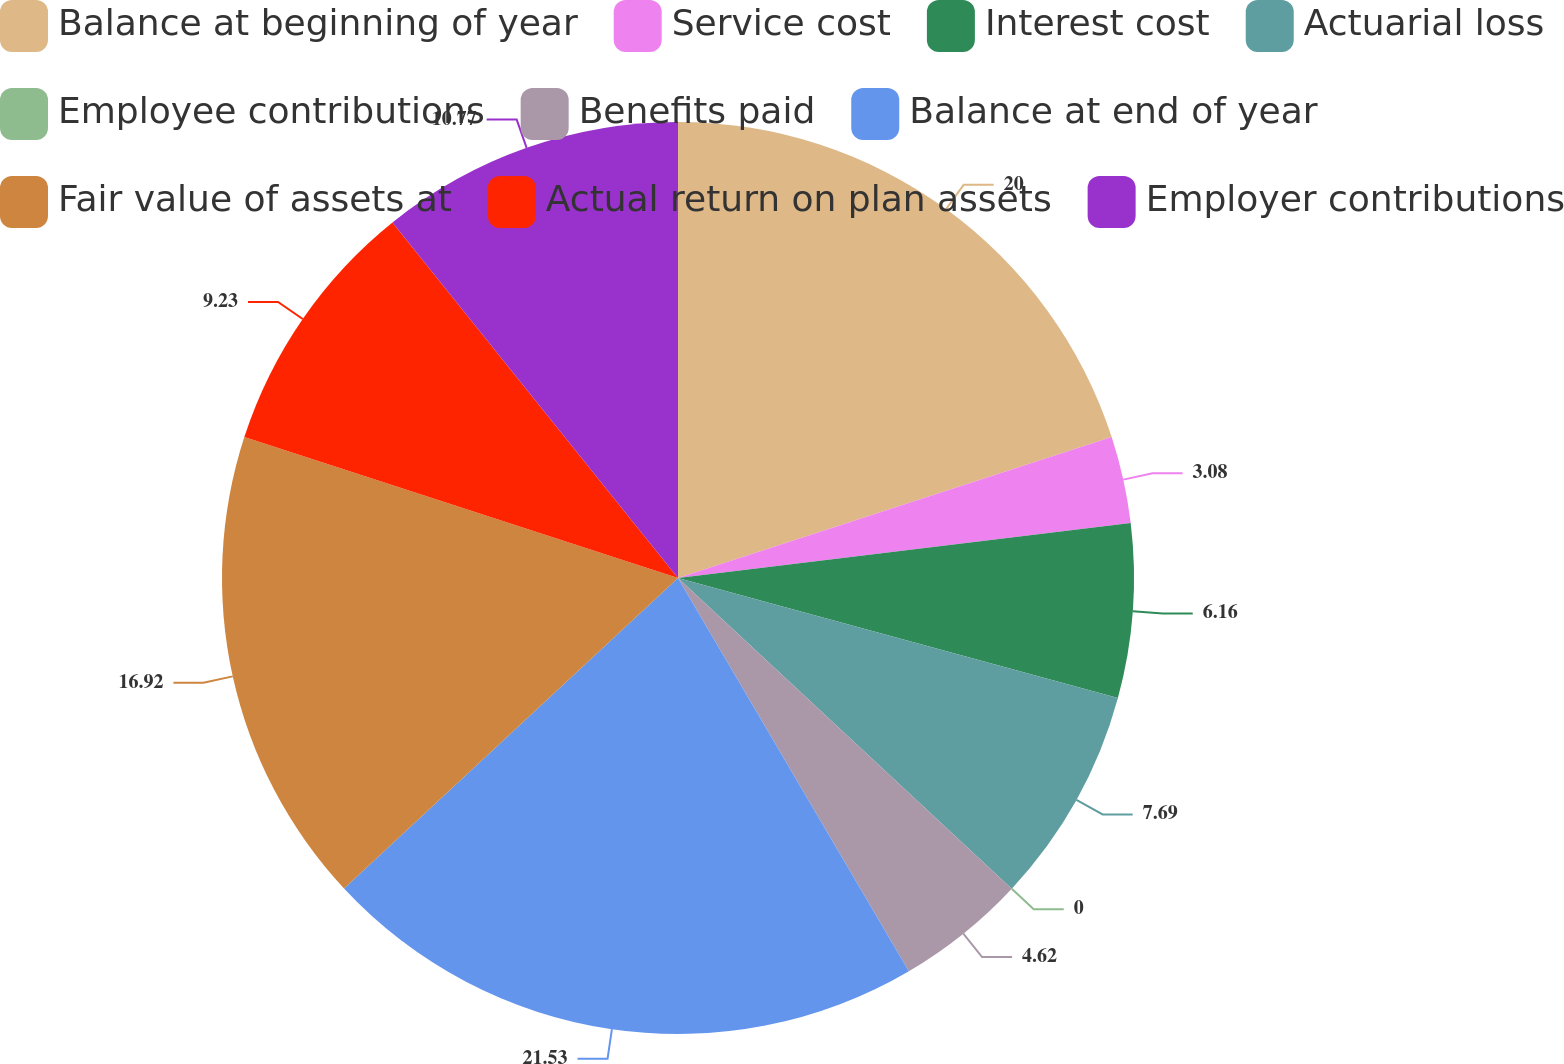Convert chart to OTSL. <chart><loc_0><loc_0><loc_500><loc_500><pie_chart><fcel>Balance at beginning of year<fcel>Service cost<fcel>Interest cost<fcel>Actuarial loss<fcel>Employee contributions<fcel>Benefits paid<fcel>Balance at end of year<fcel>Fair value of assets at<fcel>Actual return on plan assets<fcel>Employer contributions<nl><fcel>20.0%<fcel>3.08%<fcel>6.16%<fcel>7.69%<fcel>0.0%<fcel>4.62%<fcel>21.53%<fcel>16.92%<fcel>9.23%<fcel>10.77%<nl></chart> 